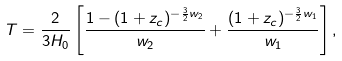<formula> <loc_0><loc_0><loc_500><loc_500>T = \frac { 2 } { 3 H _ { 0 } } \left [ \frac { 1 - ( 1 + z _ { c } ) ^ { - \frac { 3 } { 2 } w _ { 2 } } } { w _ { 2 } } + \frac { ( 1 + z _ { c } ) ^ { - \frac { 3 } { 2 } w _ { 1 } } } { w _ { 1 } } \right ] ,</formula> 